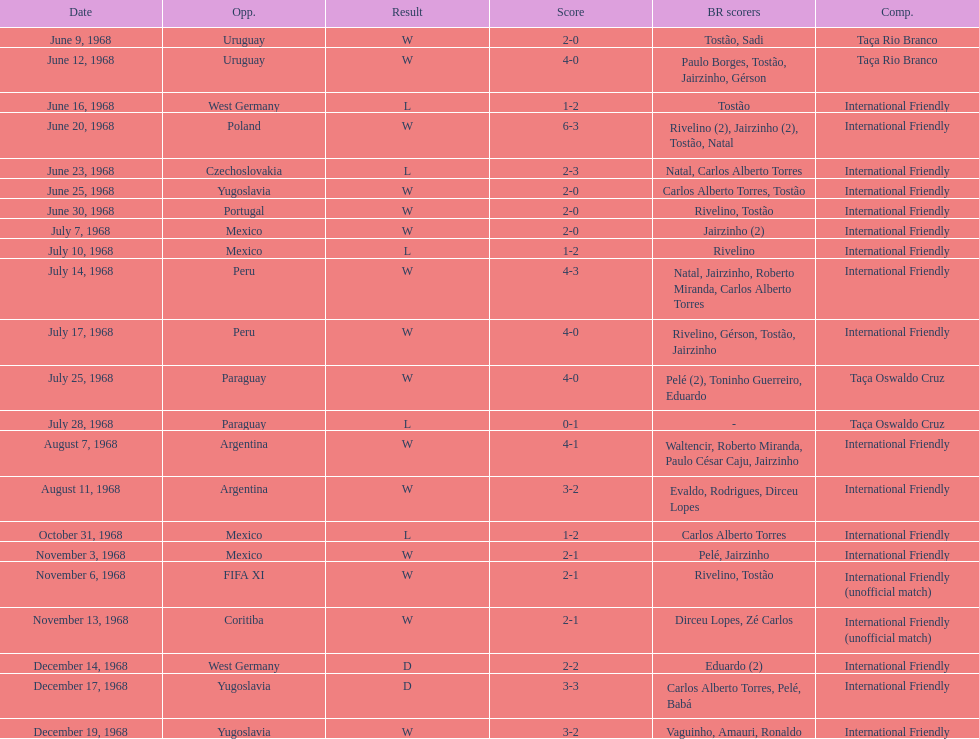How many matches are wins? 15. Can you give me this table as a dict? {'header': ['Date', 'Opp.', 'Result', 'Score', 'BR scorers', 'Comp.'], 'rows': [['June 9, 1968', 'Uruguay', 'W', '2-0', 'Tostão, Sadi', 'Taça Rio Branco'], ['June 12, 1968', 'Uruguay', 'W', '4-0', 'Paulo Borges, Tostão, Jairzinho, Gérson', 'Taça Rio Branco'], ['June 16, 1968', 'West Germany', 'L', '1-2', 'Tostão', 'International Friendly'], ['June 20, 1968', 'Poland', 'W', '6-3', 'Rivelino (2), Jairzinho (2), Tostão, Natal', 'International Friendly'], ['June 23, 1968', 'Czechoslovakia', 'L', '2-3', 'Natal, Carlos Alberto Torres', 'International Friendly'], ['June 25, 1968', 'Yugoslavia', 'W', '2-0', 'Carlos Alberto Torres, Tostão', 'International Friendly'], ['June 30, 1968', 'Portugal', 'W', '2-0', 'Rivelino, Tostão', 'International Friendly'], ['July 7, 1968', 'Mexico', 'W', '2-0', 'Jairzinho (2)', 'International Friendly'], ['July 10, 1968', 'Mexico', 'L', '1-2', 'Rivelino', 'International Friendly'], ['July 14, 1968', 'Peru', 'W', '4-3', 'Natal, Jairzinho, Roberto Miranda, Carlos Alberto Torres', 'International Friendly'], ['July 17, 1968', 'Peru', 'W', '4-0', 'Rivelino, Gérson, Tostão, Jairzinho', 'International Friendly'], ['July 25, 1968', 'Paraguay', 'W', '4-0', 'Pelé (2), Toninho Guerreiro, Eduardo', 'Taça Oswaldo Cruz'], ['July 28, 1968', 'Paraguay', 'L', '0-1', '-', 'Taça Oswaldo Cruz'], ['August 7, 1968', 'Argentina', 'W', '4-1', 'Waltencir, Roberto Miranda, Paulo César Caju, Jairzinho', 'International Friendly'], ['August 11, 1968', 'Argentina', 'W', '3-2', 'Evaldo, Rodrigues, Dirceu Lopes', 'International Friendly'], ['October 31, 1968', 'Mexico', 'L', '1-2', 'Carlos Alberto Torres', 'International Friendly'], ['November 3, 1968', 'Mexico', 'W', '2-1', 'Pelé, Jairzinho', 'International Friendly'], ['November 6, 1968', 'FIFA XI', 'W', '2-1', 'Rivelino, Tostão', 'International Friendly (unofficial match)'], ['November 13, 1968', 'Coritiba', 'W', '2-1', 'Dirceu Lopes, Zé Carlos', 'International Friendly (unofficial match)'], ['December 14, 1968', 'West Germany', 'D', '2-2', 'Eduardo (2)', 'International Friendly'], ['December 17, 1968', 'Yugoslavia', 'D', '3-3', 'Carlos Alberto Torres, Pelé, Babá', 'International Friendly'], ['December 19, 1968', 'Yugoslavia', 'W', '3-2', 'Vaguinho, Amauri, Ronaldo', 'International Friendly']]} 